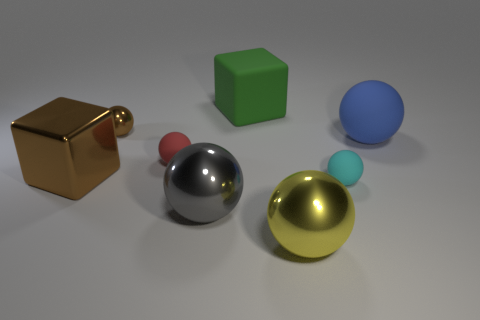Can you describe the arrangement and colors of the objects in the image? Certainly! There are five objects arranged roughly in a semicircle. Starting from the left, there's a reflective gold cube, followed by a small red sphere. Center stage, there's a matte green cube. To the right, there is a large silver sphere and behind it, a small matte blue sphere. Finally, there's a large golden-yellow sphere on the far right. 